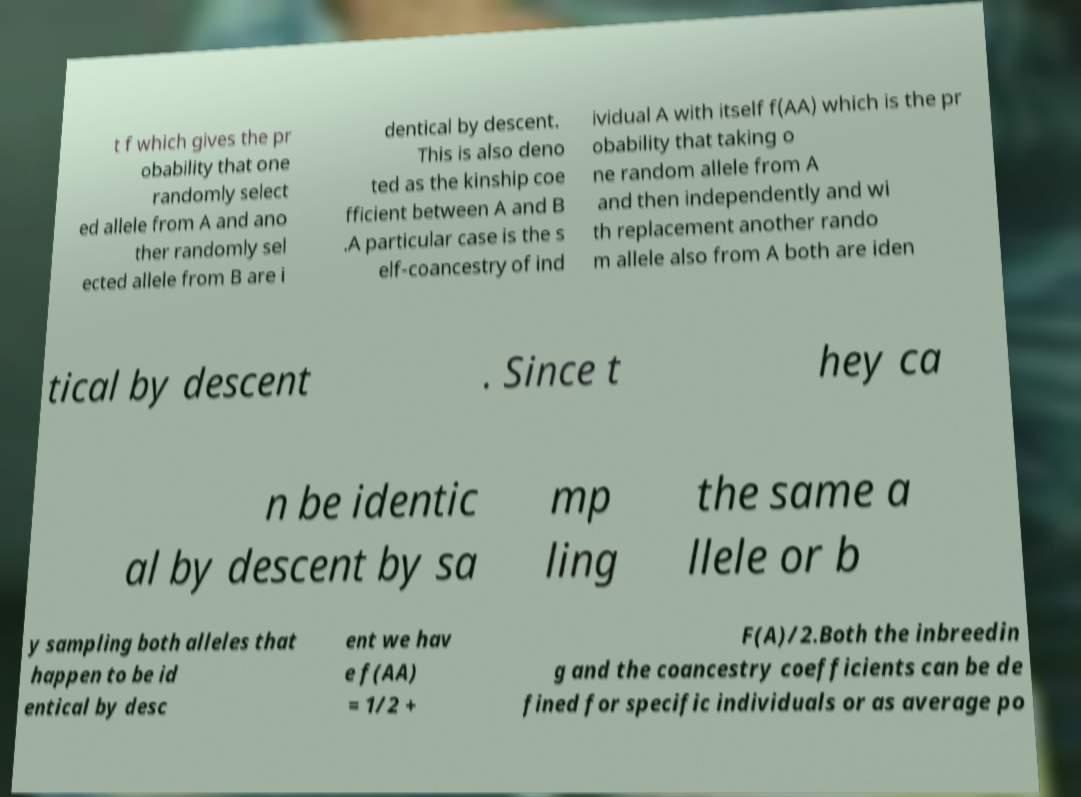For documentation purposes, I need the text within this image transcribed. Could you provide that? t f which gives the pr obability that one randomly select ed allele from A and ano ther randomly sel ected allele from B are i dentical by descent. This is also deno ted as the kinship coe fficient between A and B .A particular case is the s elf-coancestry of ind ividual A with itself f(AA) which is the pr obability that taking o ne random allele from A and then independently and wi th replacement another rando m allele also from A both are iden tical by descent . Since t hey ca n be identic al by descent by sa mp ling the same a llele or b y sampling both alleles that happen to be id entical by desc ent we hav e f(AA) = 1/2 + F(A)/2.Both the inbreedin g and the coancestry coefficients can be de fined for specific individuals or as average po 